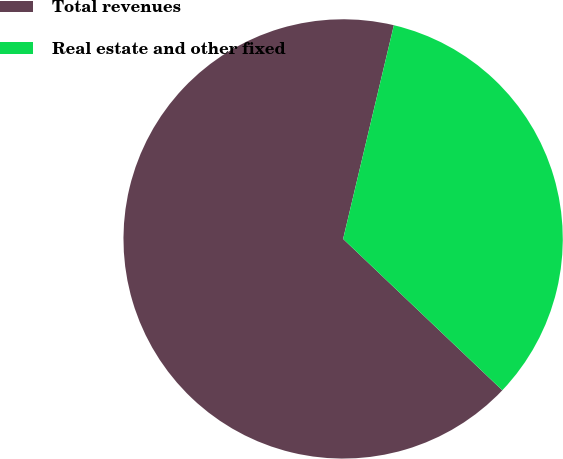<chart> <loc_0><loc_0><loc_500><loc_500><pie_chart><fcel>Total revenues<fcel>Real estate and other fixed<nl><fcel>66.61%<fcel>33.39%<nl></chart> 